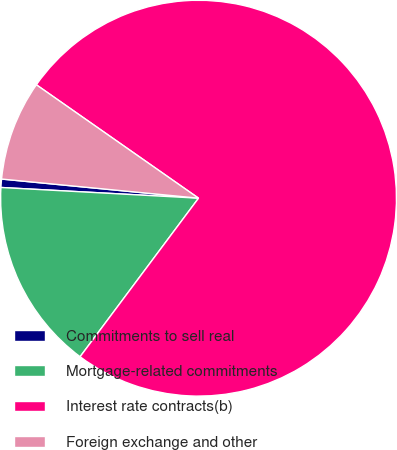Convert chart. <chart><loc_0><loc_0><loc_500><loc_500><pie_chart><fcel>Commitments to sell real<fcel>Mortgage-related commitments<fcel>Interest rate contracts(b)<fcel>Foreign exchange and other<nl><fcel>0.68%<fcel>15.65%<fcel>75.5%<fcel>8.17%<nl></chart> 